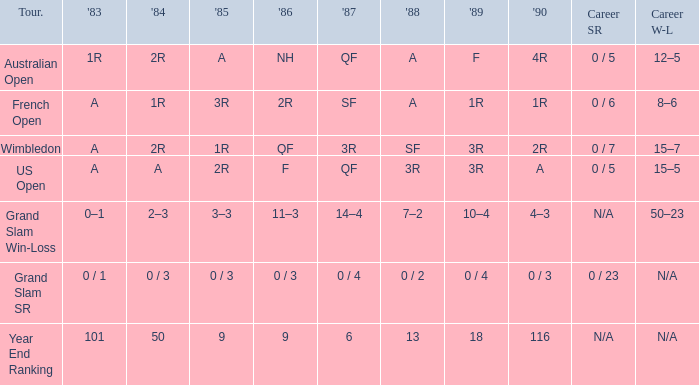Which tournament was marked as 0/1 in 1983? Grand Slam SR. 